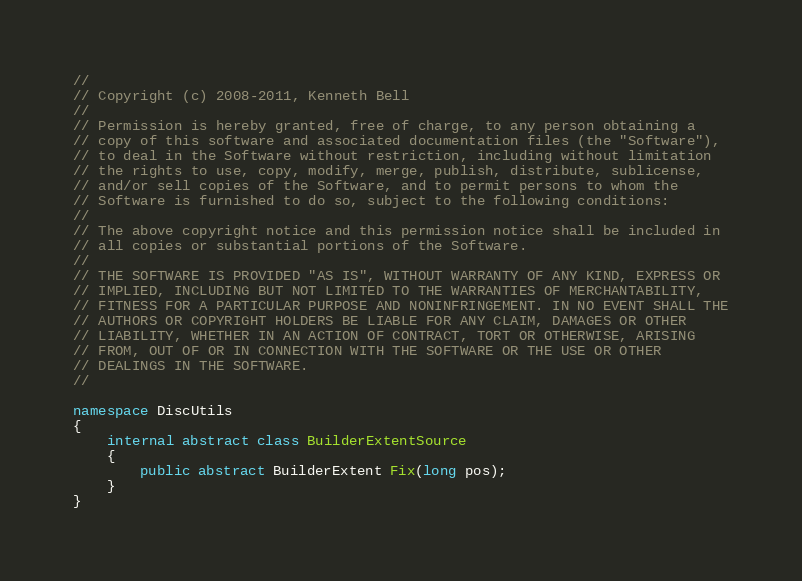<code> <loc_0><loc_0><loc_500><loc_500><_C#_>//
// Copyright (c) 2008-2011, Kenneth Bell
//
// Permission is hereby granted, free of charge, to any person obtaining a
// copy of this software and associated documentation files (the "Software"),
// to deal in the Software without restriction, including without limitation
// the rights to use, copy, modify, merge, publish, distribute, sublicense,
// and/or sell copies of the Software, and to permit persons to whom the
// Software is furnished to do so, subject to the following conditions:
//
// The above copyright notice and this permission notice shall be included in
// all copies or substantial portions of the Software.
//
// THE SOFTWARE IS PROVIDED "AS IS", WITHOUT WARRANTY OF ANY KIND, EXPRESS OR
// IMPLIED, INCLUDING BUT NOT LIMITED TO THE WARRANTIES OF MERCHANTABILITY,
// FITNESS FOR A PARTICULAR PURPOSE AND NONINFRINGEMENT. IN NO EVENT SHALL THE
// AUTHORS OR COPYRIGHT HOLDERS BE LIABLE FOR ANY CLAIM, DAMAGES OR OTHER
// LIABILITY, WHETHER IN AN ACTION OF CONTRACT, TORT OR OTHERWISE, ARISING
// FROM, OUT OF OR IN CONNECTION WITH THE SOFTWARE OR THE USE OR OTHER
// DEALINGS IN THE SOFTWARE.
//

namespace DiscUtils
{
    internal abstract class BuilderExtentSource
    {
        public abstract BuilderExtent Fix(long pos);
    }
}
</code> 